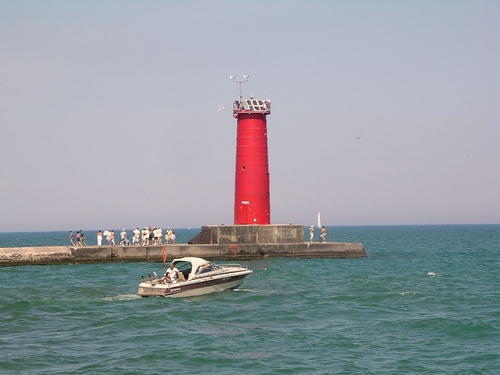Describe the objects in this image and their specific colors. I can see boat in darkgray, gray, ivory, and black tones, people in darkgray, gray, ivory, and tan tones, people in darkgray, ivory, and gray tones, people in darkgray, ivory, tan, and gray tones, and people in darkgray, gray, and lightpink tones in this image. 